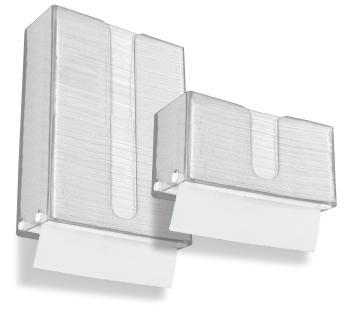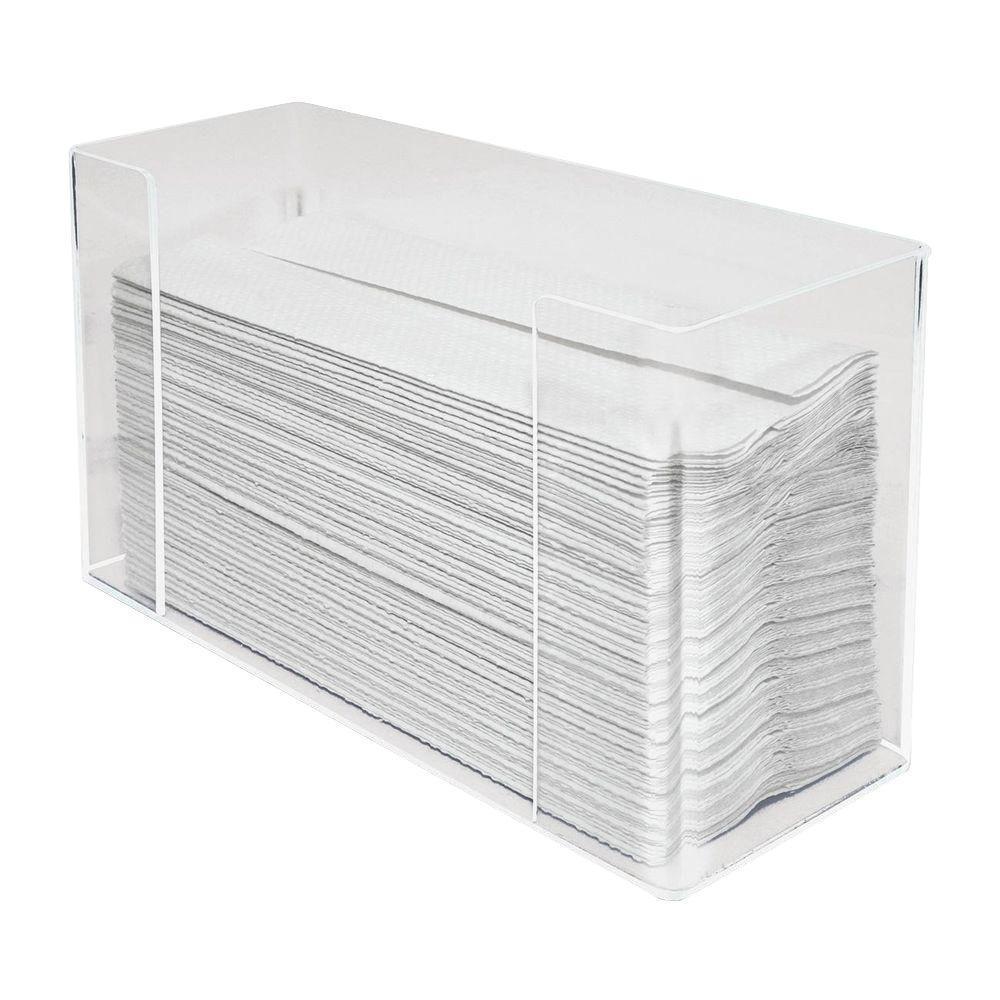The first image is the image on the left, the second image is the image on the right. For the images shown, is this caption "Different style holders are shown in the left and right images, and the right image features an upright oblong opaque holder with a paper towel sticking out of its top." true? Answer yes or no. No. The first image is the image on the left, the second image is the image on the right. Evaluate the accuracy of this statement regarding the images: "A paper is poking out of the dispenser in the image on the right.". Is it true? Answer yes or no. No. 